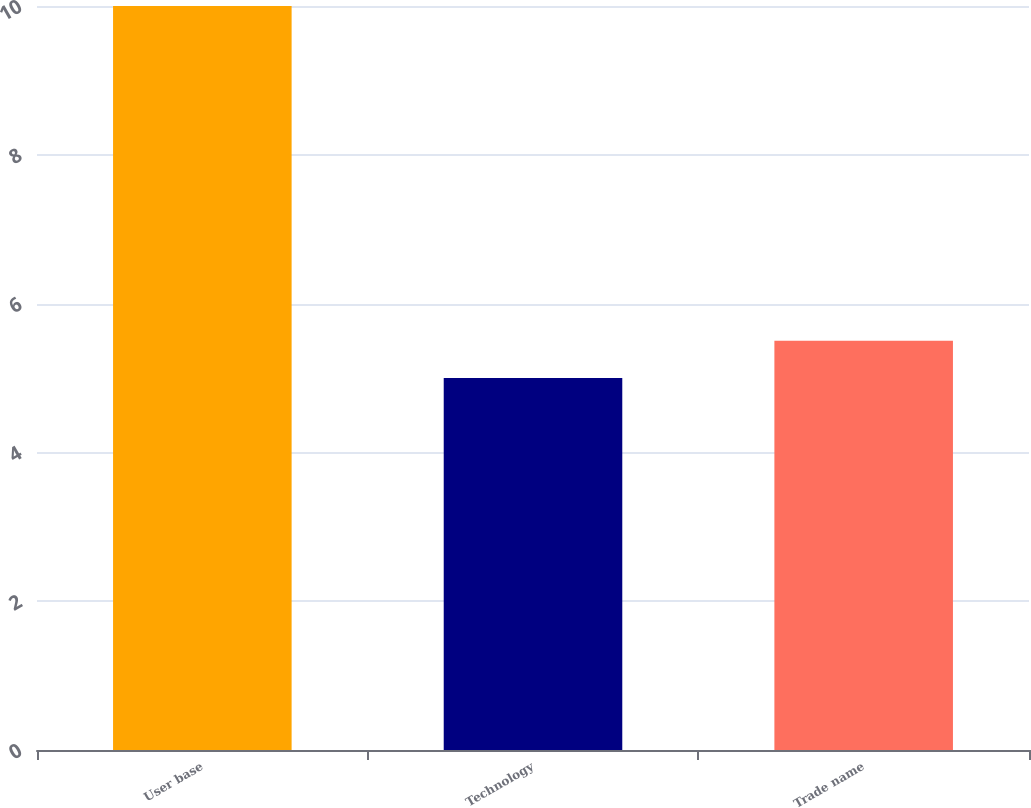<chart> <loc_0><loc_0><loc_500><loc_500><bar_chart><fcel>User base<fcel>Technology<fcel>Trade name<nl><fcel>10<fcel>5<fcel>5.5<nl></chart> 